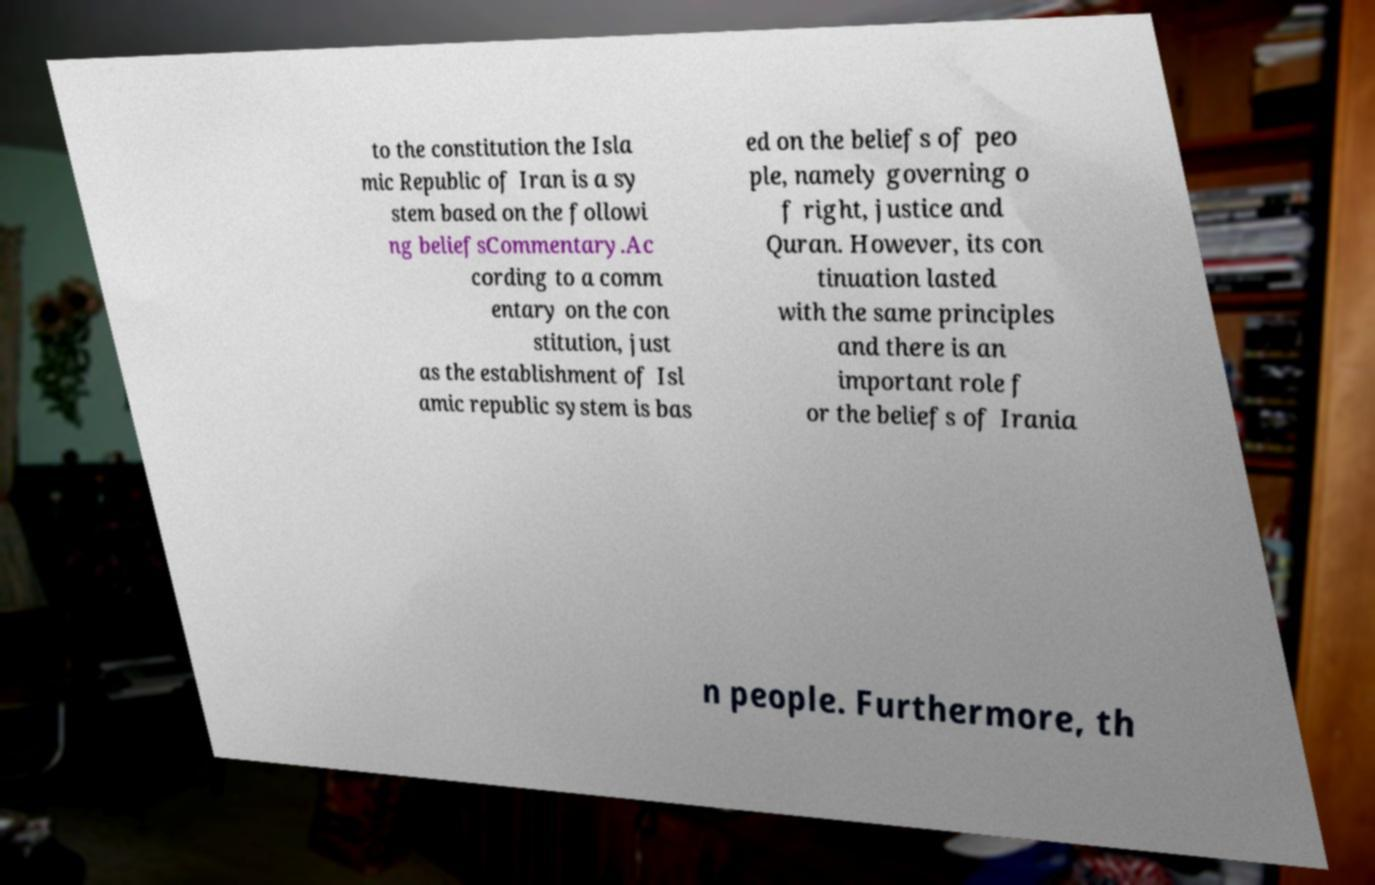Please identify and transcribe the text found in this image. to the constitution the Isla mic Republic of Iran is a sy stem based on the followi ng beliefsCommentary.Ac cording to a comm entary on the con stitution, just as the establishment of Isl amic republic system is bas ed on the beliefs of peo ple, namely governing o f right, justice and Quran. However, its con tinuation lasted with the same principles and there is an important role f or the beliefs of Irania n people. Furthermore, th 